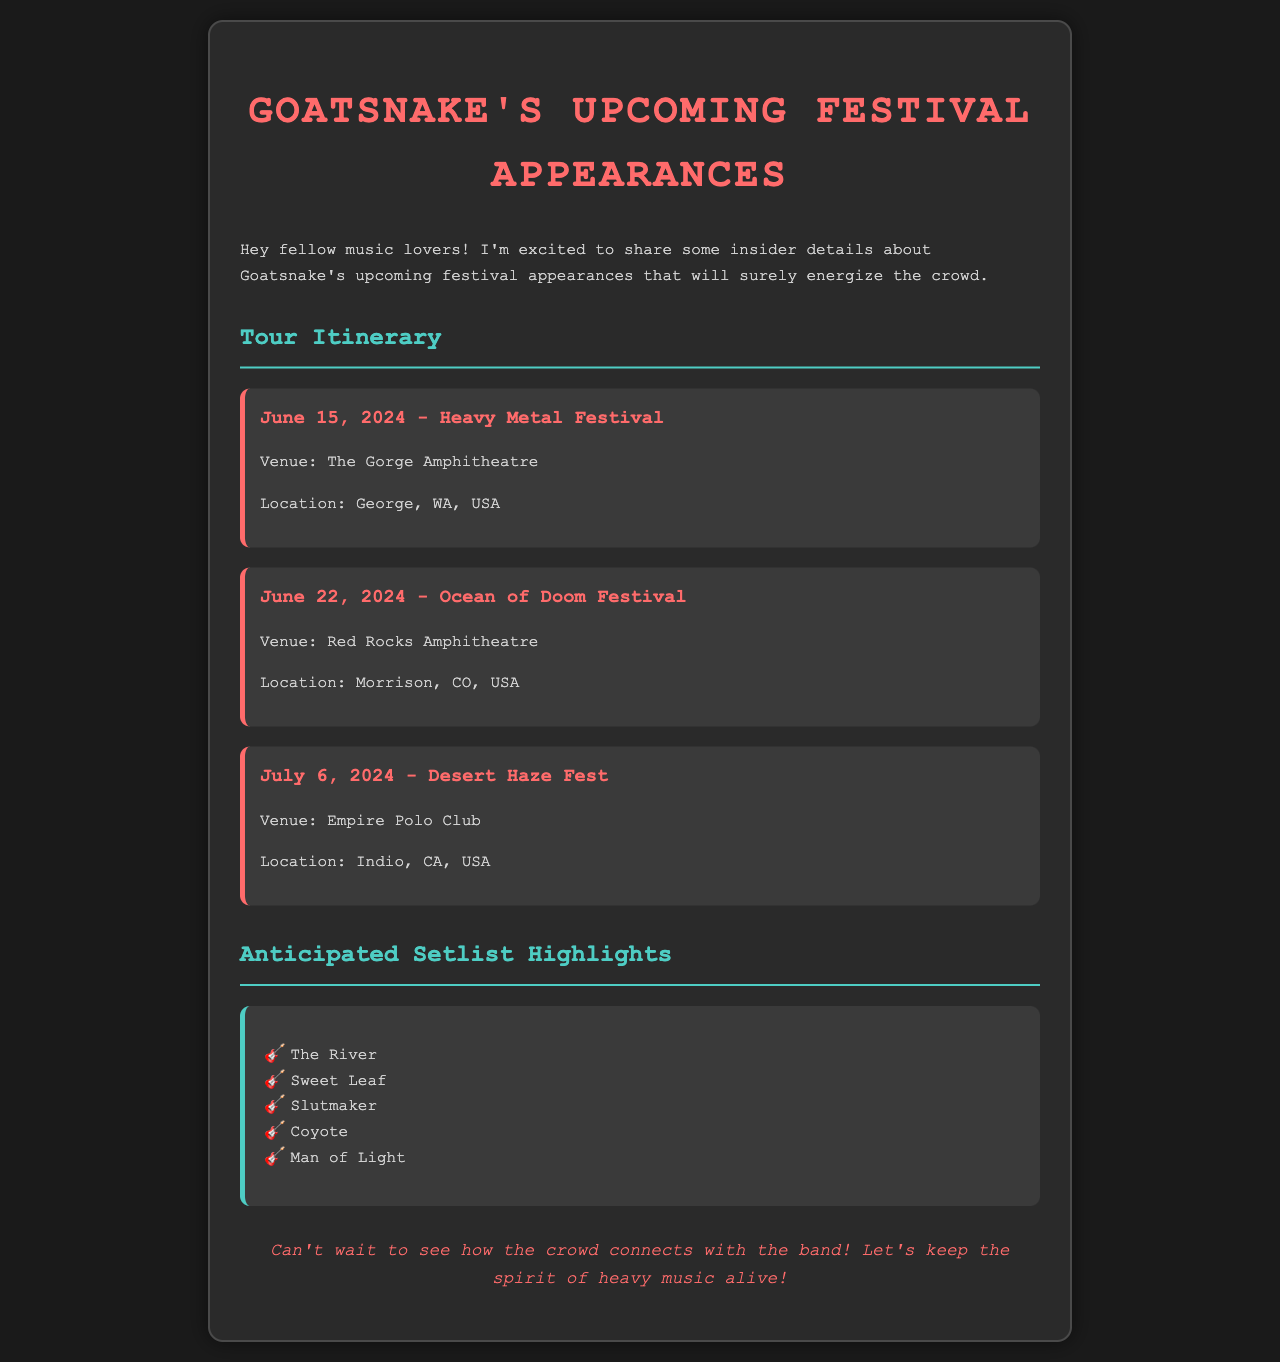What is the first festival Goatsnake will perform at? The first festival listed in the itinerary is the Heavy Metal Festival on June 15, 2024.
Answer: Heavy Metal Festival What venue will host the Ocean of Doom Festival? The document explicitly states that the Ocean of Doom Festival will be held at Red Rocks Amphitheatre.
Answer: Red Rocks Amphitheatre What date is the Desert Haze Fest scheduled for? According to the itinerary, the Desert Haze Fest is scheduled for July 6, 2024.
Answer: July 6, 2024 How many festivals are mentioned in the tour itinerary? The document lists a total of three festivals where Goatsnake will perform.
Answer: Three What is one anticipated setlist highlight mentioned? The setlist preview mentions multiple songs; one highlight listed is "The River."
Answer: The River Which location will the Heavy Metal Festival take place? The Heavy Metal Festival is set to take place in George, WA, USA, as mentioned in the document.
Answer: George, WA, USA What is the color of the main heading in the document? The main heading is colored in a bright shade, specified as #ff6b6b in the styling.
Answer: #ff6b6b Name a venue where Goatsnake will perform in June 2024. The Ocean of Doom Festival takes place at Red Rocks Amphitheatre, one of the venues.
Answer: Red Rocks Amphitheatre 